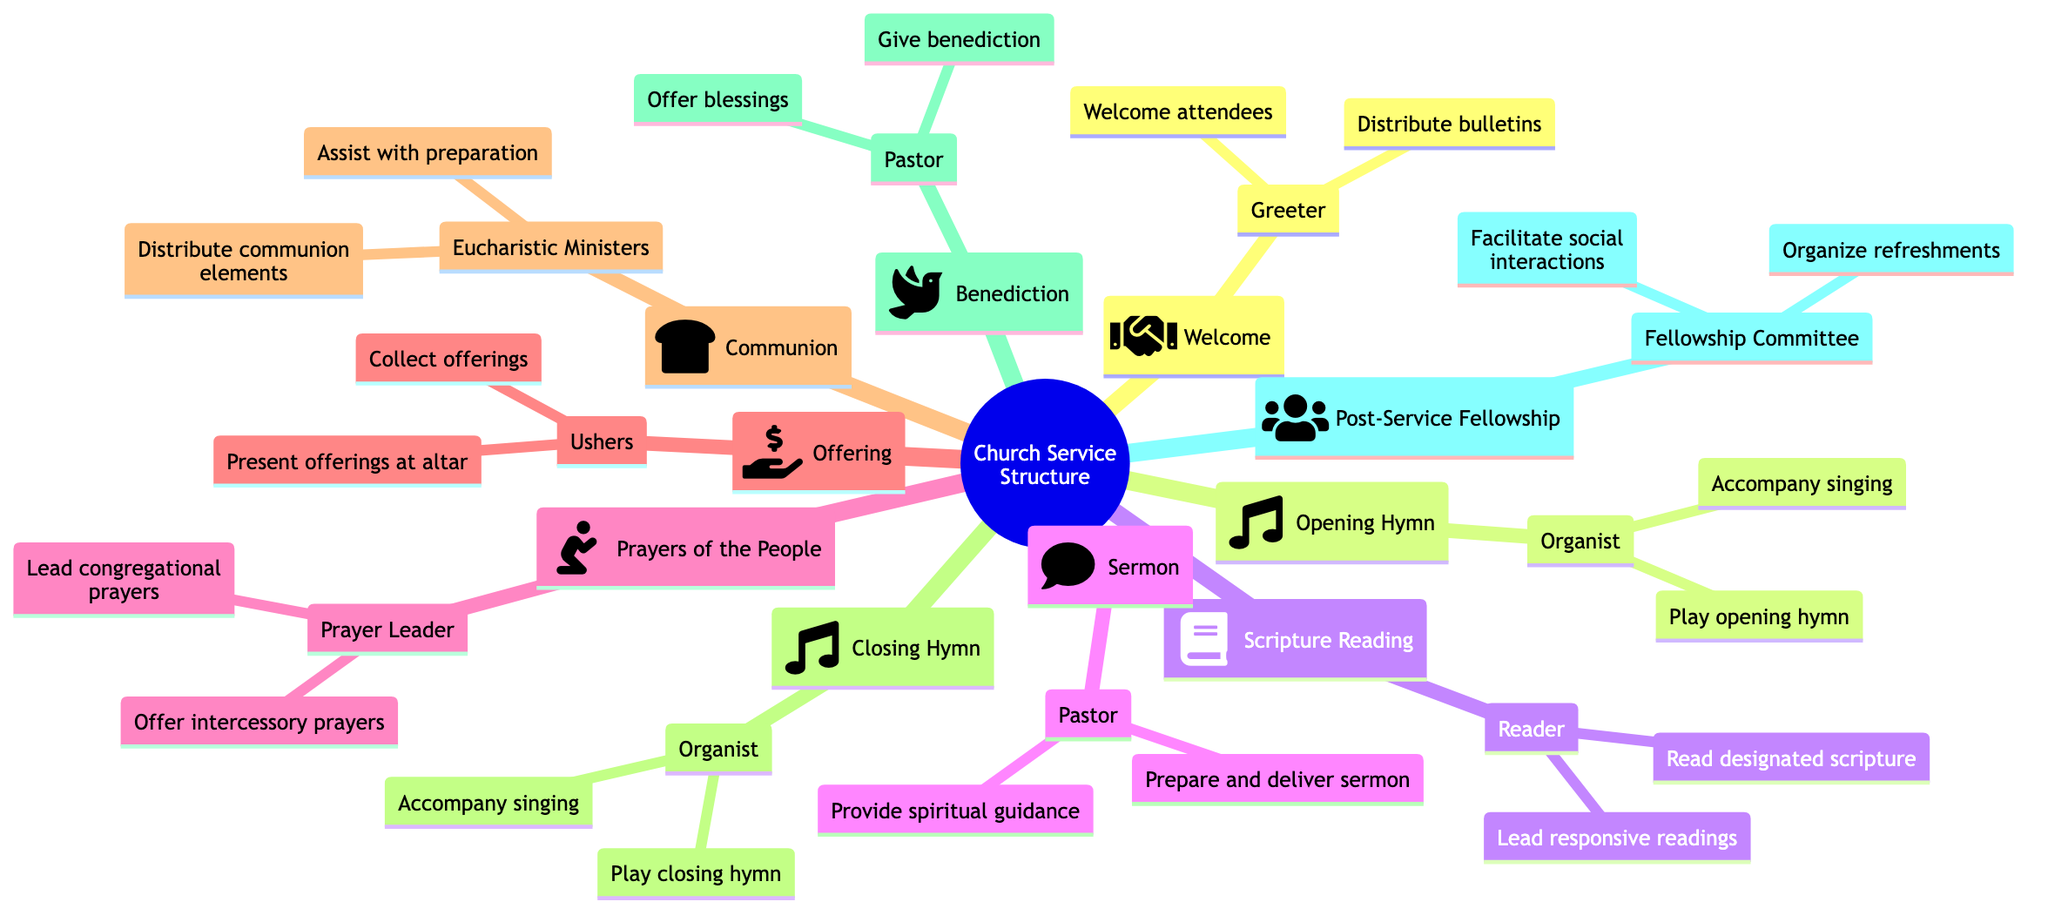What is the first role mentioned in the diagram? The diagram begins with the "Welcome" section, which identifies the role of "Greeter."
Answer: Greeter How many hymns are played during the service? The structure includes two hymns: "Opening Hymn" and "Closing Hymn." Count them in the diagram.
Answer: 2 Who is responsible for leading the "Prayers of the People"? In the diagram, the section "Prayers of the People" lists the "Prayer Leader" as responsible for that role.
Answer: Prayer Leader What are the responsibilities of the "Ushers"? Under the "Offering" section, the responsibilities of "Ushers" are outlined as "Collect offerings" and "Present offerings at the altar." Both responsibilities can be found there.
Answer: Collect offerings, Present offerings at the altar Which role has two responsibilities listed that involve preparing and delivering? The "Sermon" identifies the "Pastor" as having the responsibilities "Prepare and deliver sermon" and "Provide spiritual guidance." This can be seen clearly in the diagram.
Answer: Pastor During which segment is communion distributed? The "Communion" section of the diagram indicates that "Eucharistic Ministers" distribute communion elements as part of their responsibilities.
Answer: Communion What is the last segment of the service mentioned in the diagram? The final section of the diagram is "Post-Service Fellowship," which is the last part of the church service structure.
Answer: Post-Service Fellowship How many roles are directly involved in music during the service? The diagram shows that "Organist" plays a role in both "Opening Hymn" and "Closing Hymn," which totals to one distinct role involved in music.
Answer: 1 What is the role responsible for organizing refreshments? The "Fellowship Committee" is mentioned in the "Post-Service Fellowship," indicating their responsibility to organize refreshments and facilitate social interactions. This is clear from the diagram.
Answer: Fellowship Committee 